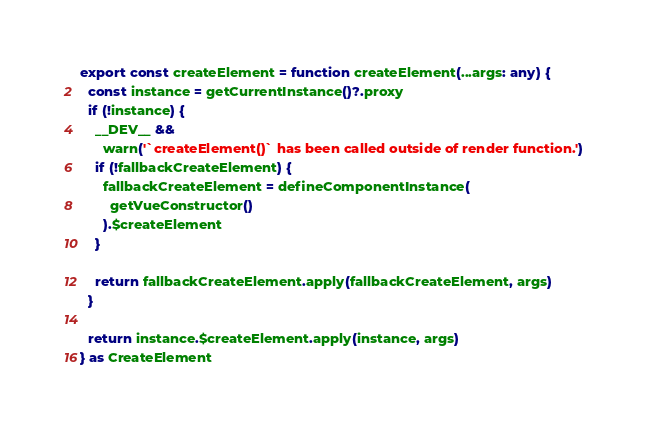<code> <loc_0><loc_0><loc_500><loc_500><_TypeScript_>export const createElement = function createElement(...args: any) {
  const instance = getCurrentInstance()?.proxy
  if (!instance) {
    __DEV__ &&
      warn('`createElement()` has been called outside of render function.')
    if (!fallbackCreateElement) {
      fallbackCreateElement = defineComponentInstance(
        getVueConstructor()
      ).$createElement
    }

    return fallbackCreateElement.apply(fallbackCreateElement, args)
  }

  return instance.$createElement.apply(instance, args)
} as CreateElement
</code> 